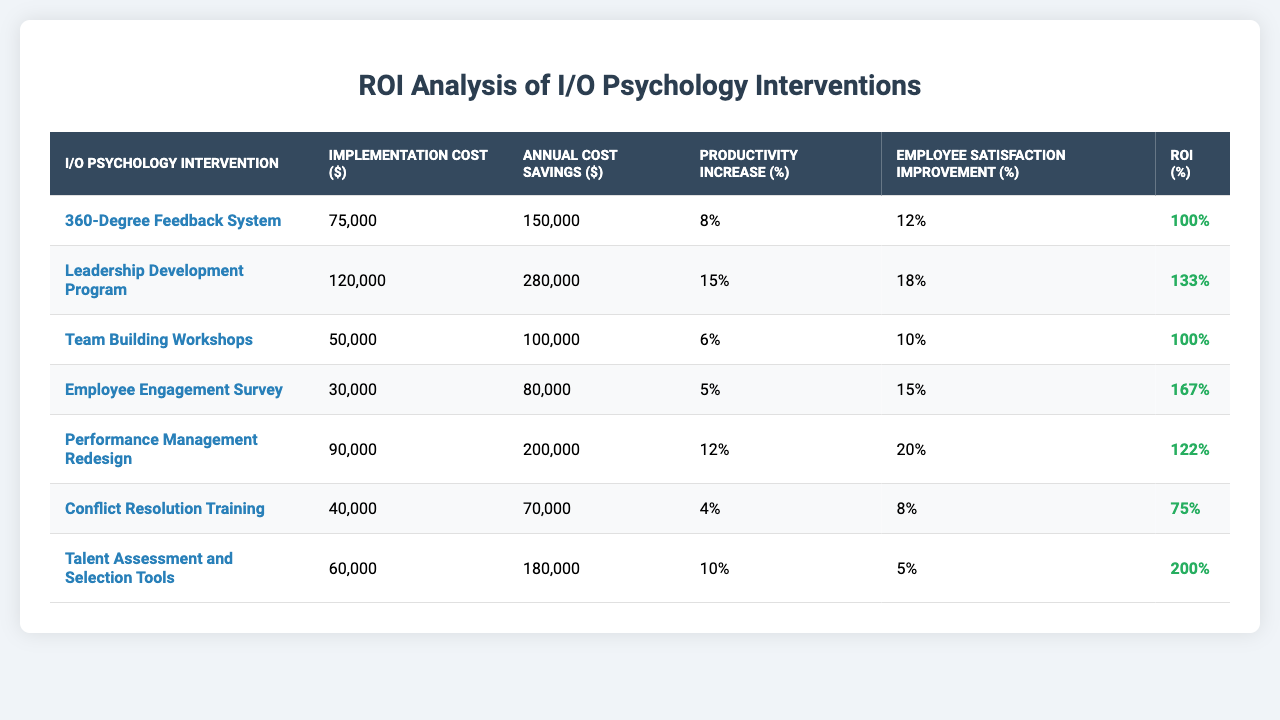What is the highest ROI percentage among the interventions listed? The intervention with the highest ROI percentage is the "Talent Assessment and Selection Tools" with an ROI of 200%.
Answer: 200% Which intervention had the lowest implementation cost? The intervention with the lowest implementation cost is the "Employee Engagement Survey," costing $30,000.
Answer: $30,000 What is the average annual cost savings across all interventions? The total annual cost savings is $1,030,000, and there are 7 interventions, so the average annual cost savings is $1,030,000 / 7 ≈ $147,143.
Answer: $147,143 Did the "Conflict Resolution Training" improve employee satisfaction by more than 10%? No, the "Conflict Resolution Training" showed an employee satisfaction improvement of only 8%.
Answer: No What is the difference in implementation cost between the "Leadership Development Program" and the "Team Building Workshops"? The "Leadership Development Program" costs $120,000 and the "Team Building Workshops" costs $50,000, so the difference is $120,000 - $50,000 = $70,000.
Answer: $70,000 Which two interventions together provide the highest total productivity increase percentage? The "Leadership Development Program" (15%) and "Performance Management Redesign" (12%) together yield a total productivity increase of 15% + 12% = 27%.
Answer: 27% How many interventions have an ROI greater than 100%? There are four interventions with an ROI greater than 100%: "Leadership Development Program," "Employee Engagement Survey," "Performance Management Redesign," and "Talent Assessment and Selection Tools."
Answer: 4 What is the implementation cost of the "360-Degree Feedback System"? The implementation cost of the "360-Degree Feedback System" is $75,000.
Answer: $75,000 Is the annual cost savings from the "Employee Engagement Survey" greater than that of the "Conflict Resolution Training"? Yes, the "Employee Engagement Survey" provides annual cost savings of $80,000, which is greater than the $70,000 from "Conflict Resolution Training."
Answer: Yes Which intervention has the highest improvement in employee satisfaction? The "Performance Management Redesign" has the highest improvement in employee satisfaction at 20%.
Answer: 20% 